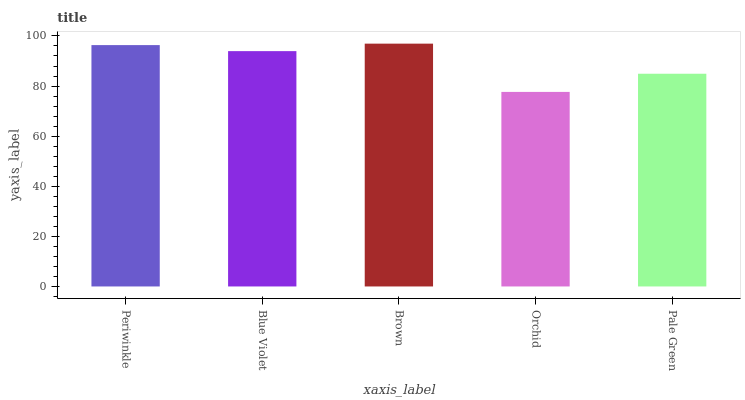Is Blue Violet the minimum?
Answer yes or no. No. Is Blue Violet the maximum?
Answer yes or no. No. Is Periwinkle greater than Blue Violet?
Answer yes or no. Yes. Is Blue Violet less than Periwinkle?
Answer yes or no. Yes. Is Blue Violet greater than Periwinkle?
Answer yes or no. No. Is Periwinkle less than Blue Violet?
Answer yes or no. No. Is Blue Violet the high median?
Answer yes or no. Yes. Is Blue Violet the low median?
Answer yes or no. Yes. Is Periwinkle the high median?
Answer yes or no. No. Is Periwinkle the low median?
Answer yes or no. No. 